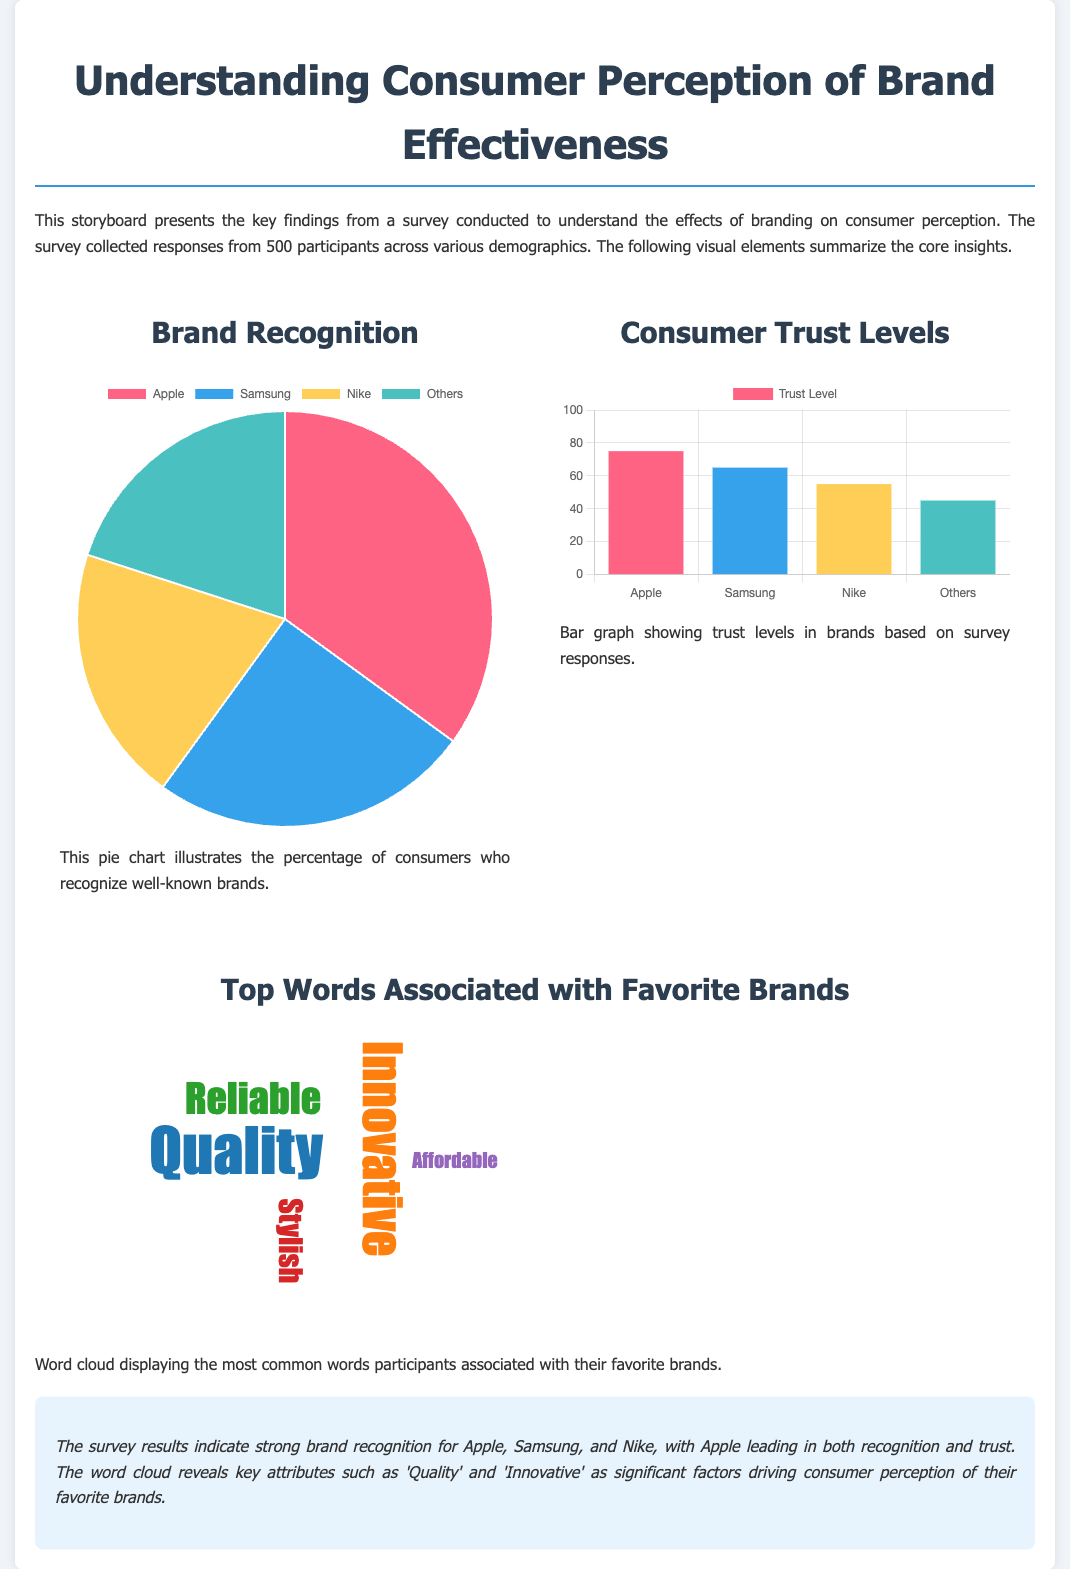What is the title of the document? The title of the document is displayed prominently at the top of the storyboard.
Answer: Understanding Consumer Perception of Brand Effectiveness How many participants were surveyed? The document mentions that responses were collected from 500 participants.
Answer: 500 Which brand has the highest recognition percentage? The pie chart indicates the percentage of recognition for various brands.
Answer: Apple What is the trust level for Samsung? The bar chart provides specific trust levels for different brands.
Answer: 65 What are the top two words associated with favorite brands? The word cloud displays the most common words associated with brands, with the largest words being the most significant.
Answer: Quality, Innovative What is the maximum trust level shown on the bar graph? The y-axis of the bar graph indicates the maximum value for trust levels.
Answer: 100 Which colors are used in the pie chart? The document explicitly lists the background colors for different segments of the pie chart.
Answer: Pink, Blue, Yellow, Teal What type of visual representation is used for brand recognition? The document specifies the format of the visual representation of brand recognition.
Answer: Pie chart What is the background color of the conclusion section? The document describes the background color of the conclusion section for visual clarity.
Answer: Light blue 